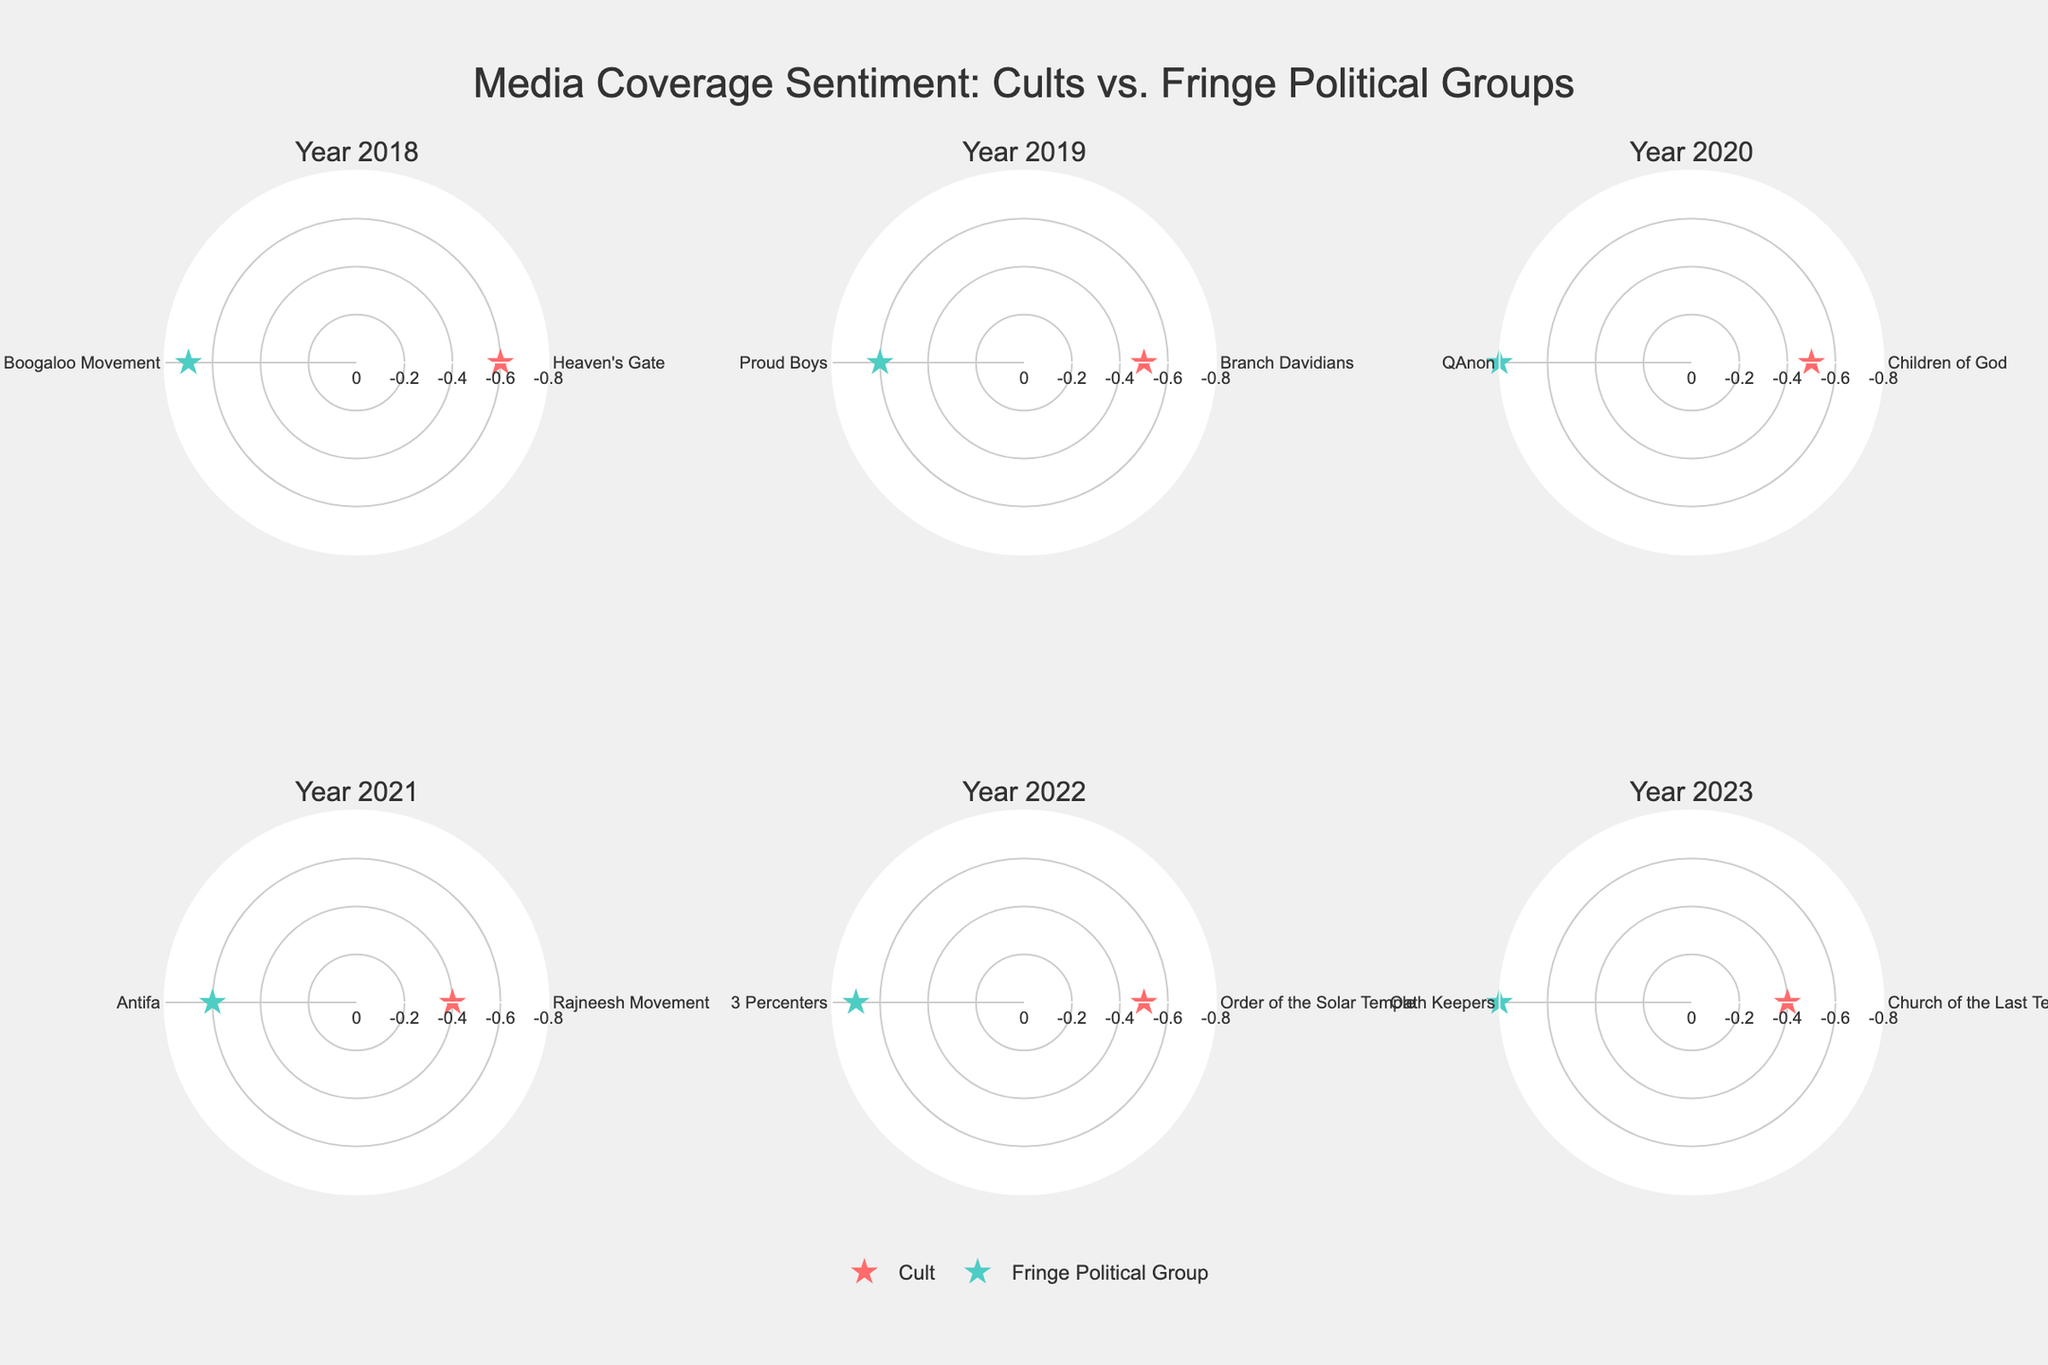What is the subtitle of the figure for the subplots in 2020? Each subplot has its own subtitle stating the year it represents. Locate the subplot for 2020 to identify its subtitle.
Answer: 'Year 2020' How many data points are plotted for the year 2021? Each subplot shows two points, one for a cult and one for a fringe political group. Identify the subplot for 2021 and count the data points.
Answer: Two Which subgroup had a more negative sentiment in 2022? Compare the radial axis values for the cult and fringe political group in the subplot for 2022 to identify which is closer to -0.8.
Answer: Fringe Political Group What is the range of radial axis values shown in all subplots? Observe the radial axis on any subplot and note the minimum and maximum values listed.
Answer: 0 to -0.8 Between 2018 and 2023, which group showed an overall more negative media sentiment, cults or fringe political groups? Observe the points across all subplots noting the sentiment values. Cult points are stars colored in specific hues, while fringe political group points are colored differently. Compare their positions relative to -0.8.
Answer: Fringe political groups How many years have the sentiment value for cults being exactly -0.5? Identify the years for each subplot, then check whether the sentiment value of the cult equals -0.5 in each year.
Answer: Three years (2019, 2020, 2022) In 2023, which entity received a more negative media sentiment? Locate the subplot for 2023, then compare the positions of the two entities on the radial axis to see which is closer to -0.8.
Answer: Oath Keepers What color is used to represent fringe political groups in the figure? Examine the markers (symbols) legend to see which color corresponds to the fringe political group.
Answer: Teal (or similar representation based on the figure color) Which year had the least negative sentiment for cults? Identify and compare the sentiment values for cults in each of the subplots to find the highest value (least negative).
Answer: 2023 